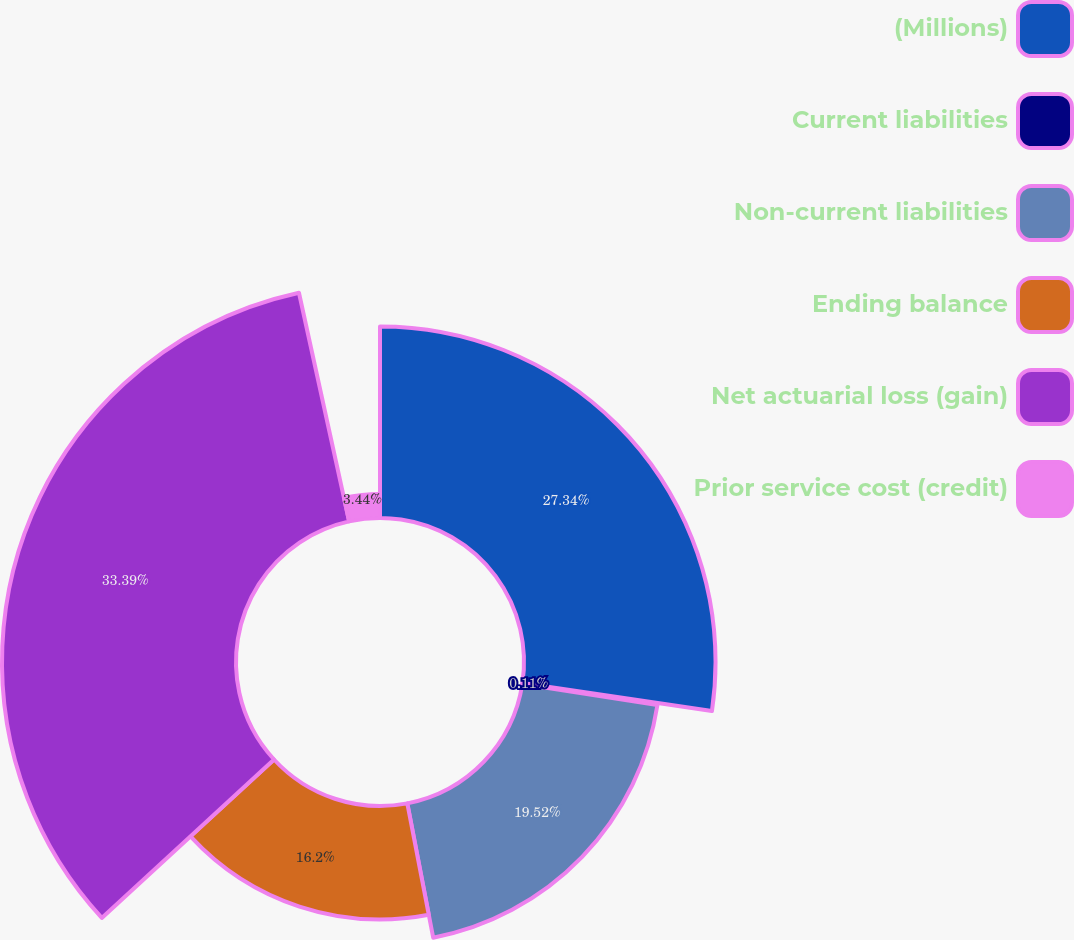Convert chart to OTSL. <chart><loc_0><loc_0><loc_500><loc_500><pie_chart><fcel>(Millions)<fcel>Current liabilities<fcel>Non-current liabilities<fcel>Ending balance<fcel>Net actuarial loss (gain)<fcel>Prior service cost (credit)<nl><fcel>27.34%<fcel>0.11%<fcel>19.52%<fcel>16.2%<fcel>33.4%<fcel>3.44%<nl></chart> 